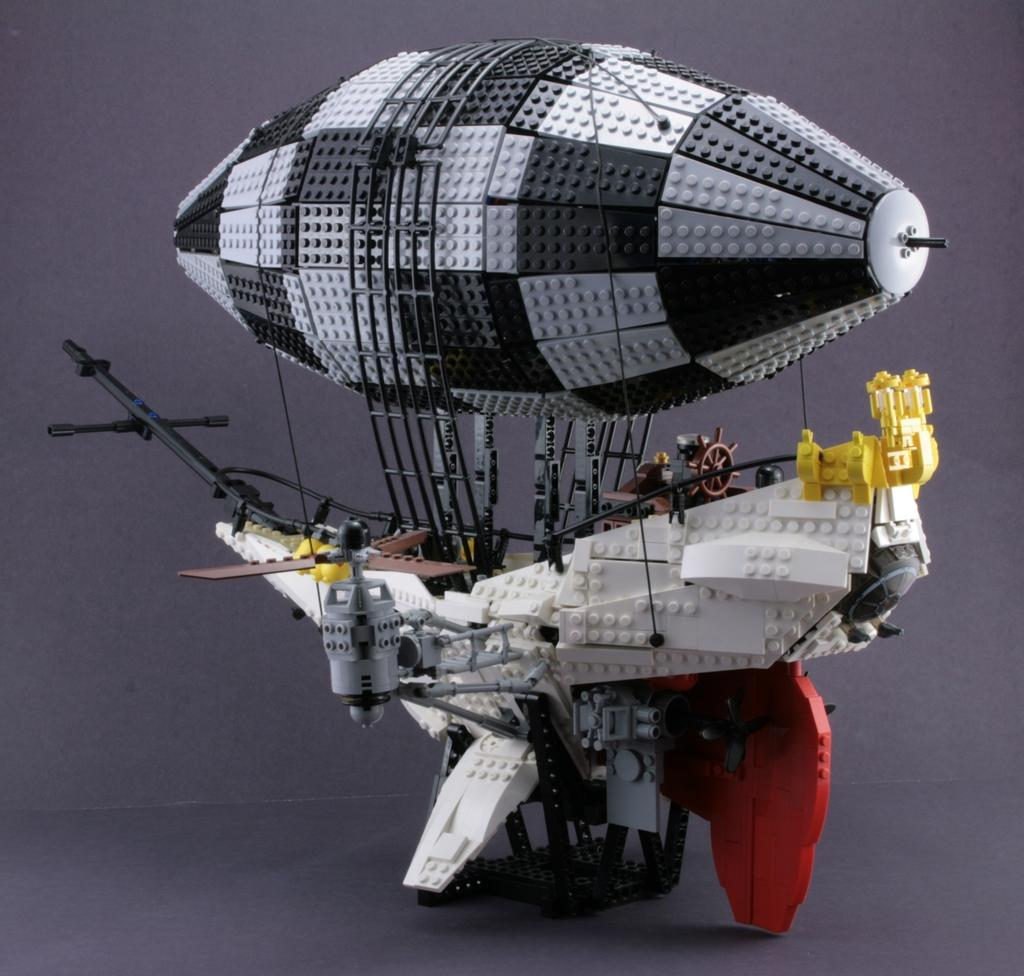What type of vehicle is depicted in the image? There is a lego airship in the image. Can you describe a specific feature of the airship? The airship has a fan on the left side. What safety feature is included on the airship? The airship has a parachute. What type of polish is used to maintain the airship's appearance in the image? There is no mention of polish or any maintenance activity in the image, as it features a lego airship with a fan and a parachute. 